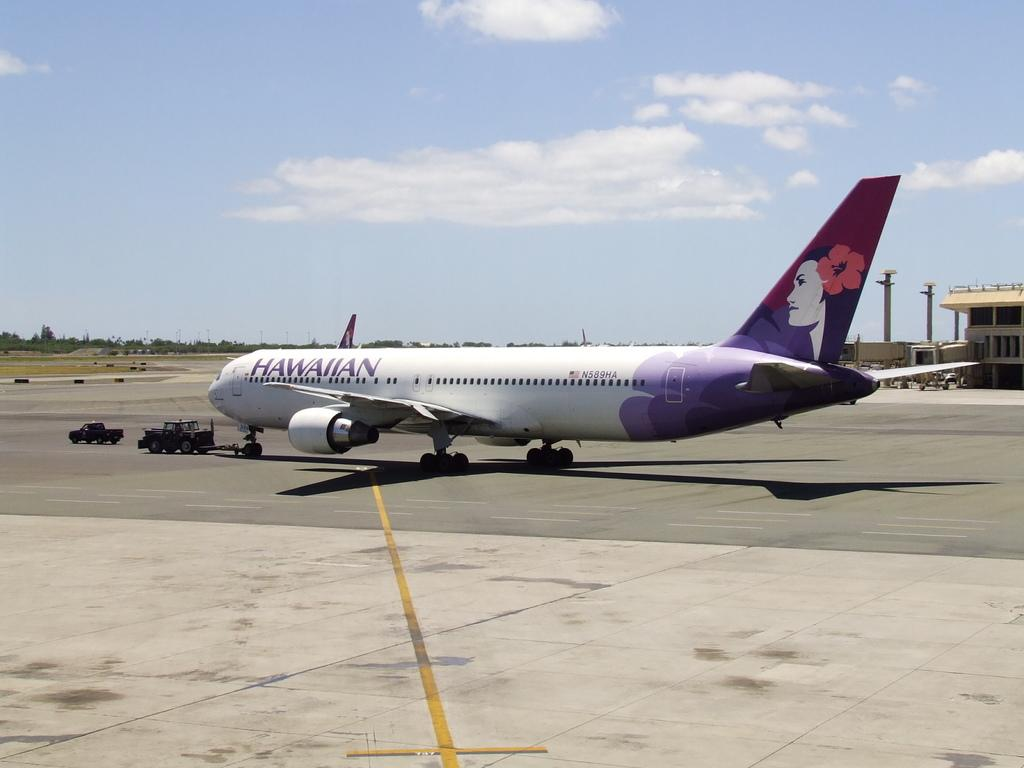<image>
Write a terse but informative summary of the picture. An airplane belonging to Hawaiian Airlines sits on the airport tarmac. 